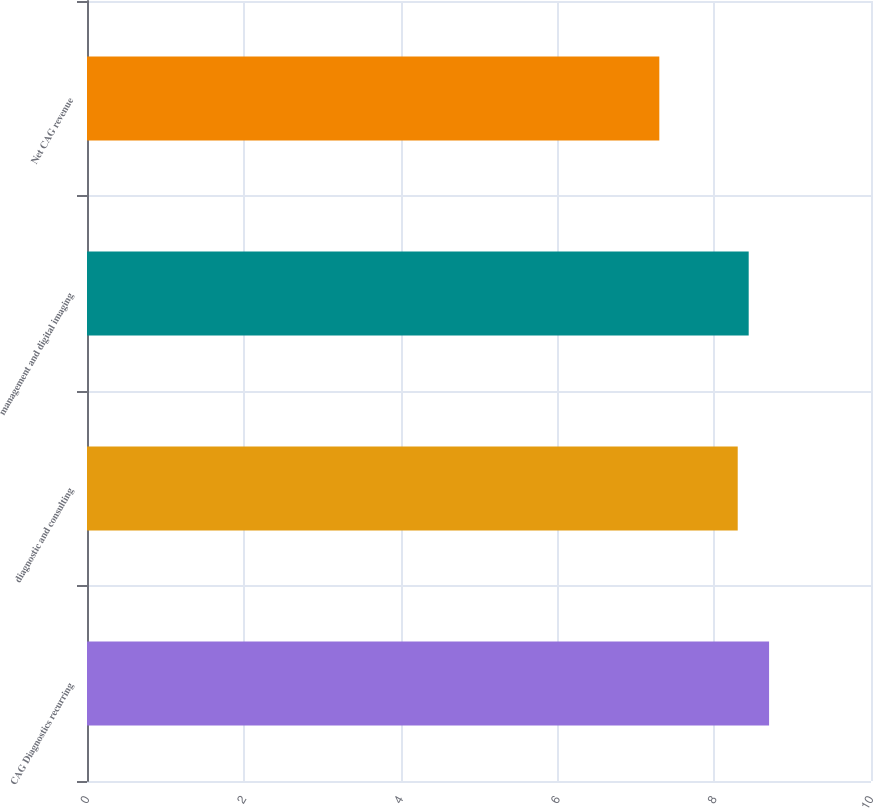<chart> <loc_0><loc_0><loc_500><loc_500><bar_chart><fcel>CAG Diagnostics recurring<fcel>diagnostic and consulting<fcel>management and digital imaging<fcel>Net CAG revenue<nl><fcel>8.7<fcel>8.3<fcel>8.44<fcel>7.3<nl></chart> 